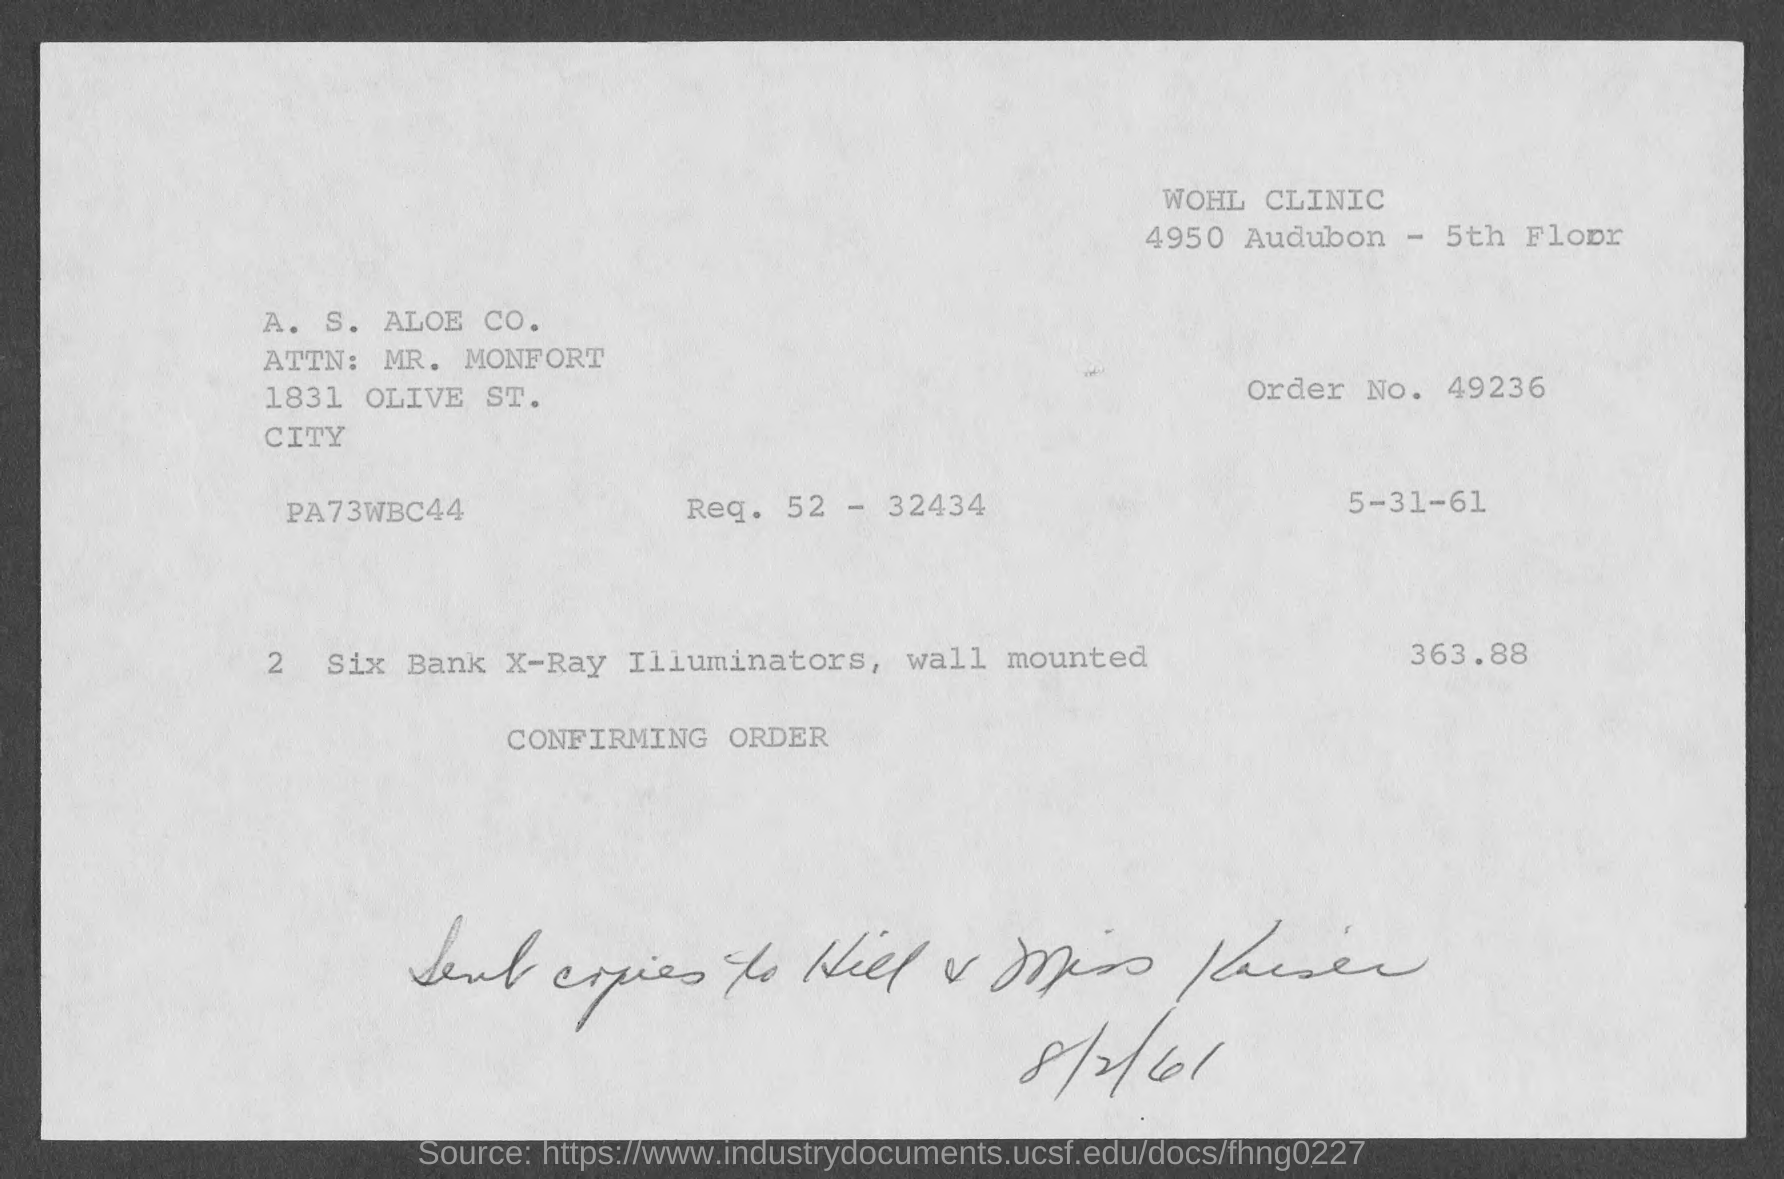Point out several critical features in this image. The price of the bill is 363.88 cents. The clinic is located on the 5th floor. The order number is 49236.... 